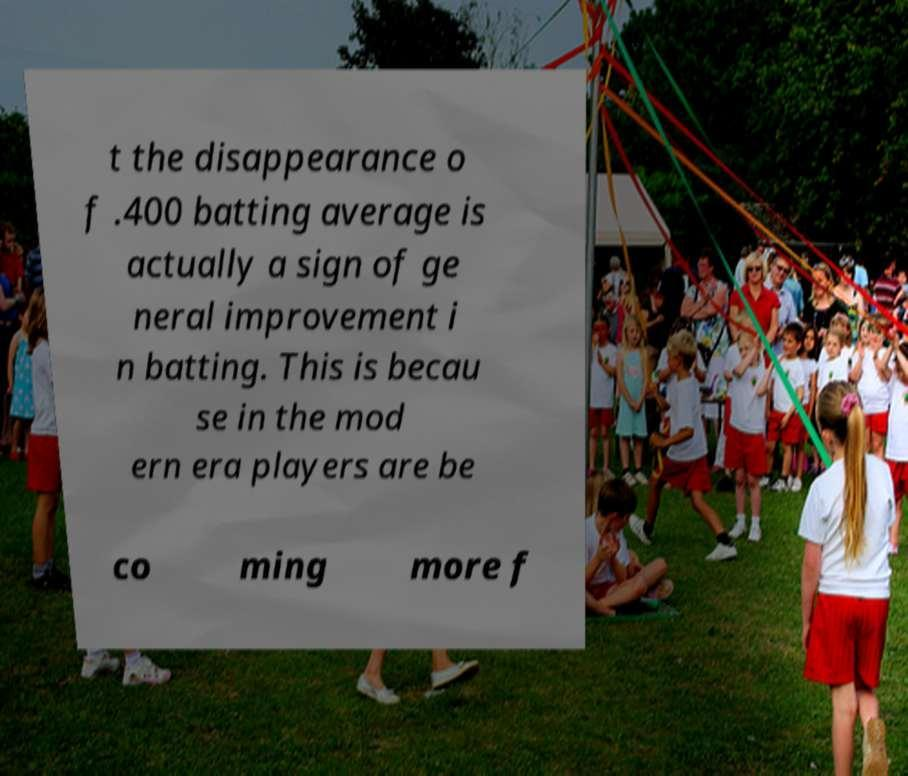What messages or text are displayed in this image? I need them in a readable, typed format. t the disappearance o f .400 batting average is actually a sign of ge neral improvement i n batting. This is becau se in the mod ern era players are be co ming more f 